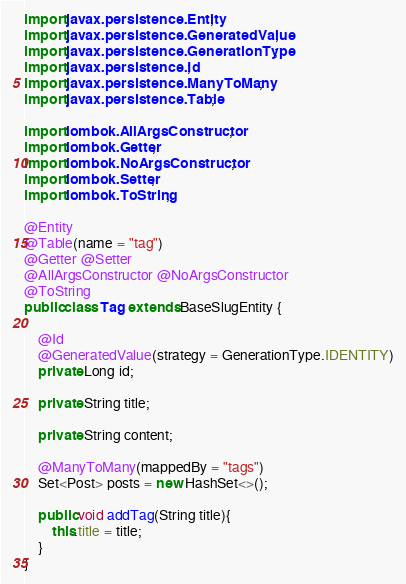Convert code to text. <code><loc_0><loc_0><loc_500><loc_500><_Java_>
import javax.persistence.Entity;
import javax.persistence.GeneratedValue;
import javax.persistence.GenerationType;
import javax.persistence.Id;
import javax.persistence.ManyToMany;
import javax.persistence.Table;

import lombok.AllArgsConstructor;
import lombok.Getter;
import lombok.NoArgsConstructor;
import lombok.Setter;
import lombok.ToString;

@Entity
@Table(name = "tag")
@Getter @Setter
@AllArgsConstructor @NoArgsConstructor
@ToString
public class Tag extends BaseSlugEntity {
    
    @Id
    @GeneratedValue(strategy = GenerationType.IDENTITY)
    private Long id;

    private String title;

    private String content;
    
    @ManyToMany(mappedBy = "tags")
    Set<Post> posts = new HashSet<>();

    public void addTag(String title){
        this.title = title;
    }
}
</code> 